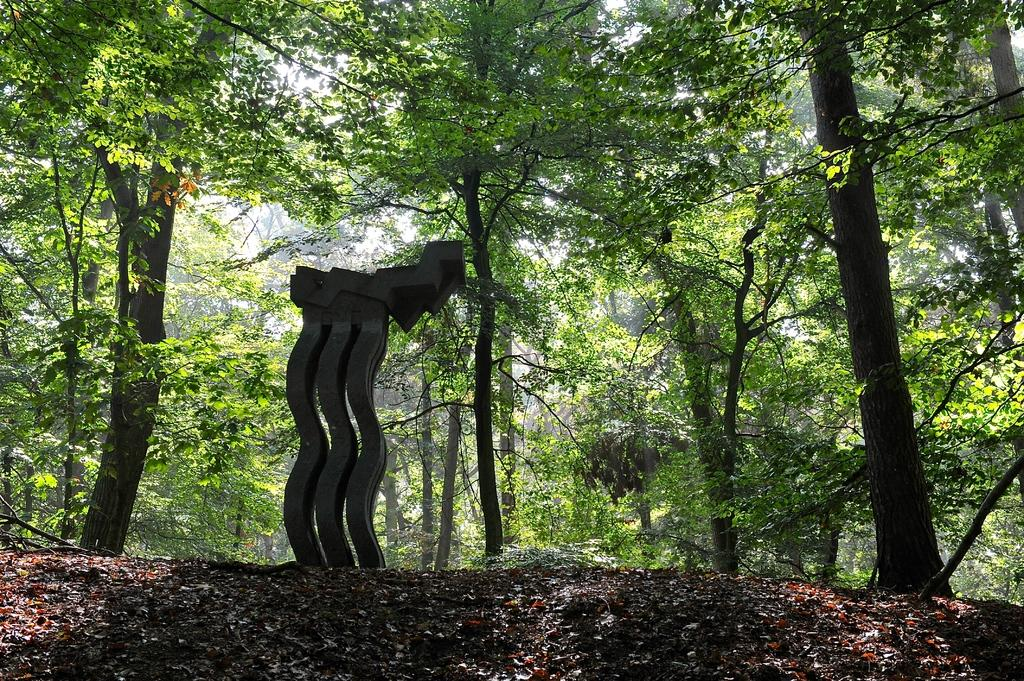What is the main subject of the image? There is a sculpture in the image. What can be seen in the background of the image? There are trees visible behind the sculpture. What type of umbrella is being used to increase the noise level in the image? There is no umbrella present in the image, and no noise level is mentioned or depicted. 